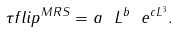Convert formula to latex. <formula><loc_0><loc_0><loc_500><loc_500>\tau f l i p ^ { M R S } = a \ L ^ { b } \ e ^ { c L ^ { 3 } } .</formula> 